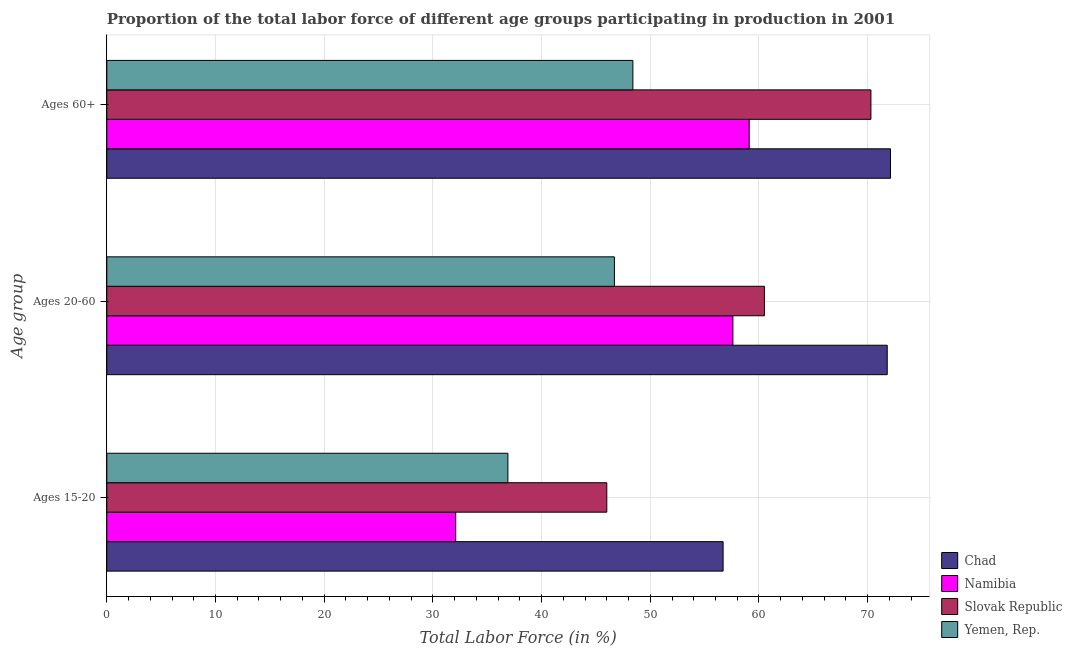Are the number of bars per tick equal to the number of legend labels?
Your response must be concise. Yes. Are the number of bars on each tick of the Y-axis equal?
Your answer should be very brief. Yes. How many bars are there on the 1st tick from the bottom?
Your response must be concise. 4. What is the label of the 2nd group of bars from the top?
Your answer should be compact. Ages 20-60. What is the percentage of labor force within the age group 20-60 in Slovak Republic?
Ensure brevity in your answer.  60.5. Across all countries, what is the maximum percentage of labor force within the age group 20-60?
Make the answer very short. 71.8. Across all countries, what is the minimum percentage of labor force above age 60?
Give a very brief answer. 48.4. In which country was the percentage of labor force within the age group 20-60 maximum?
Ensure brevity in your answer.  Chad. In which country was the percentage of labor force within the age group 20-60 minimum?
Your answer should be very brief. Yemen, Rep. What is the total percentage of labor force above age 60 in the graph?
Keep it short and to the point. 249.9. What is the difference between the percentage of labor force above age 60 in Yemen, Rep. and that in Namibia?
Offer a very short reply. -10.7. What is the difference between the percentage of labor force within the age group 20-60 in Yemen, Rep. and the percentage of labor force within the age group 15-20 in Slovak Republic?
Make the answer very short. 0.7. What is the average percentage of labor force within the age group 15-20 per country?
Provide a succinct answer. 42.93. What is the ratio of the percentage of labor force above age 60 in Namibia to that in Chad?
Give a very brief answer. 0.82. Is the difference between the percentage of labor force above age 60 in Slovak Republic and Namibia greater than the difference between the percentage of labor force within the age group 20-60 in Slovak Republic and Namibia?
Provide a short and direct response. Yes. What is the difference between the highest and the second highest percentage of labor force within the age group 15-20?
Provide a succinct answer. 10.7. What is the difference between the highest and the lowest percentage of labor force above age 60?
Ensure brevity in your answer.  23.7. In how many countries, is the percentage of labor force within the age group 15-20 greater than the average percentage of labor force within the age group 15-20 taken over all countries?
Provide a succinct answer. 2. What does the 1st bar from the top in Ages 60+ represents?
Offer a very short reply. Yemen, Rep. What does the 1st bar from the bottom in Ages 60+ represents?
Give a very brief answer. Chad. Is it the case that in every country, the sum of the percentage of labor force within the age group 15-20 and percentage of labor force within the age group 20-60 is greater than the percentage of labor force above age 60?
Provide a succinct answer. Yes. Are all the bars in the graph horizontal?
Offer a very short reply. Yes. What is the title of the graph?
Ensure brevity in your answer.  Proportion of the total labor force of different age groups participating in production in 2001. Does "Belarus" appear as one of the legend labels in the graph?
Your answer should be compact. No. What is the label or title of the Y-axis?
Offer a very short reply. Age group. What is the Total Labor Force (in %) of Chad in Ages 15-20?
Your answer should be very brief. 56.7. What is the Total Labor Force (in %) of Namibia in Ages 15-20?
Make the answer very short. 32.1. What is the Total Labor Force (in %) in Slovak Republic in Ages 15-20?
Provide a short and direct response. 46. What is the Total Labor Force (in %) of Yemen, Rep. in Ages 15-20?
Your answer should be compact. 36.9. What is the Total Labor Force (in %) of Chad in Ages 20-60?
Offer a terse response. 71.8. What is the Total Labor Force (in %) of Namibia in Ages 20-60?
Make the answer very short. 57.6. What is the Total Labor Force (in %) in Slovak Republic in Ages 20-60?
Your response must be concise. 60.5. What is the Total Labor Force (in %) in Yemen, Rep. in Ages 20-60?
Keep it short and to the point. 46.7. What is the Total Labor Force (in %) in Chad in Ages 60+?
Ensure brevity in your answer.  72.1. What is the Total Labor Force (in %) in Namibia in Ages 60+?
Make the answer very short. 59.1. What is the Total Labor Force (in %) of Slovak Republic in Ages 60+?
Your answer should be very brief. 70.3. What is the Total Labor Force (in %) in Yemen, Rep. in Ages 60+?
Keep it short and to the point. 48.4. Across all Age group, what is the maximum Total Labor Force (in %) in Chad?
Give a very brief answer. 72.1. Across all Age group, what is the maximum Total Labor Force (in %) in Namibia?
Provide a succinct answer. 59.1. Across all Age group, what is the maximum Total Labor Force (in %) in Slovak Republic?
Keep it short and to the point. 70.3. Across all Age group, what is the maximum Total Labor Force (in %) of Yemen, Rep.?
Provide a succinct answer. 48.4. Across all Age group, what is the minimum Total Labor Force (in %) in Chad?
Give a very brief answer. 56.7. Across all Age group, what is the minimum Total Labor Force (in %) of Namibia?
Your answer should be very brief. 32.1. Across all Age group, what is the minimum Total Labor Force (in %) of Yemen, Rep.?
Ensure brevity in your answer.  36.9. What is the total Total Labor Force (in %) in Chad in the graph?
Give a very brief answer. 200.6. What is the total Total Labor Force (in %) in Namibia in the graph?
Your answer should be compact. 148.8. What is the total Total Labor Force (in %) in Slovak Republic in the graph?
Provide a succinct answer. 176.8. What is the total Total Labor Force (in %) of Yemen, Rep. in the graph?
Provide a short and direct response. 132. What is the difference between the Total Labor Force (in %) in Chad in Ages 15-20 and that in Ages 20-60?
Ensure brevity in your answer.  -15.1. What is the difference between the Total Labor Force (in %) in Namibia in Ages 15-20 and that in Ages 20-60?
Ensure brevity in your answer.  -25.5. What is the difference between the Total Labor Force (in %) of Chad in Ages 15-20 and that in Ages 60+?
Make the answer very short. -15.4. What is the difference between the Total Labor Force (in %) of Namibia in Ages 15-20 and that in Ages 60+?
Make the answer very short. -27. What is the difference between the Total Labor Force (in %) of Slovak Republic in Ages 15-20 and that in Ages 60+?
Provide a short and direct response. -24.3. What is the difference between the Total Labor Force (in %) in Chad in Ages 20-60 and that in Ages 60+?
Keep it short and to the point. -0.3. What is the difference between the Total Labor Force (in %) of Yemen, Rep. in Ages 20-60 and that in Ages 60+?
Your response must be concise. -1.7. What is the difference between the Total Labor Force (in %) of Chad in Ages 15-20 and the Total Labor Force (in %) of Namibia in Ages 20-60?
Give a very brief answer. -0.9. What is the difference between the Total Labor Force (in %) of Namibia in Ages 15-20 and the Total Labor Force (in %) of Slovak Republic in Ages 20-60?
Your response must be concise. -28.4. What is the difference between the Total Labor Force (in %) of Namibia in Ages 15-20 and the Total Labor Force (in %) of Yemen, Rep. in Ages 20-60?
Ensure brevity in your answer.  -14.6. What is the difference between the Total Labor Force (in %) of Chad in Ages 15-20 and the Total Labor Force (in %) of Yemen, Rep. in Ages 60+?
Make the answer very short. 8.3. What is the difference between the Total Labor Force (in %) of Namibia in Ages 15-20 and the Total Labor Force (in %) of Slovak Republic in Ages 60+?
Provide a succinct answer. -38.2. What is the difference between the Total Labor Force (in %) of Namibia in Ages 15-20 and the Total Labor Force (in %) of Yemen, Rep. in Ages 60+?
Offer a very short reply. -16.3. What is the difference between the Total Labor Force (in %) of Slovak Republic in Ages 15-20 and the Total Labor Force (in %) of Yemen, Rep. in Ages 60+?
Offer a terse response. -2.4. What is the difference between the Total Labor Force (in %) in Chad in Ages 20-60 and the Total Labor Force (in %) in Namibia in Ages 60+?
Ensure brevity in your answer.  12.7. What is the difference between the Total Labor Force (in %) in Chad in Ages 20-60 and the Total Labor Force (in %) in Slovak Republic in Ages 60+?
Provide a succinct answer. 1.5. What is the difference between the Total Labor Force (in %) in Chad in Ages 20-60 and the Total Labor Force (in %) in Yemen, Rep. in Ages 60+?
Keep it short and to the point. 23.4. What is the difference between the Total Labor Force (in %) of Namibia in Ages 20-60 and the Total Labor Force (in %) of Slovak Republic in Ages 60+?
Ensure brevity in your answer.  -12.7. What is the difference between the Total Labor Force (in %) of Namibia in Ages 20-60 and the Total Labor Force (in %) of Yemen, Rep. in Ages 60+?
Your answer should be compact. 9.2. What is the difference between the Total Labor Force (in %) in Slovak Republic in Ages 20-60 and the Total Labor Force (in %) in Yemen, Rep. in Ages 60+?
Provide a succinct answer. 12.1. What is the average Total Labor Force (in %) in Chad per Age group?
Offer a very short reply. 66.87. What is the average Total Labor Force (in %) in Namibia per Age group?
Your answer should be compact. 49.6. What is the average Total Labor Force (in %) in Slovak Republic per Age group?
Provide a short and direct response. 58.93. What is the difference between the Total Labor Force (in %) of Chad and Total Labor Force (in %) of Namibia in Ages 15-20?
Provide a short and direct response. 24.6. What is the difference between the Total Labor Force (in %) of Chad and Total Labor Force (in %) of Slovak Republic in Ages 15-20?
Make the answer very short. 10.7. What is the difference between the Total Labor Force (in %) in Chad and Total Labor Force (in %) in Yemen, Rep. in Ages 15-20?
Give a very brief answer. 19.8. What is the difference between the Total Labor Force (in %) in Chad and Total Labor Force (in %) in Namibia in Ages 20-60?
Keep it short and to the point. 14.2. What is the difference between the Total Labor Force (in %) in Chad and Total Labor Force (in %) in Slovak Republic in Ages 20-60?
Your answer should be compact. 11.3. What is the difference between the Total Labor Force (in %) in Chad and Total Labor Force (in %) in Yemen, Rep. in Ages 20-60?
Your answer should be compact. 25.1. What is the difference between the Total Labor Force (in %) in Chad and Total Labor Force (in %) in Slovak Republic in Ages 60+?
Your answer should be compact. 1.8. What is the difference between the Total Labor Force (in %) in Chad and Total Labor Force (in %) in Yemen, Rep. in Ages 60+?
Ensure brevity in your answer.  23.7. What is the difference between the Total Labor Force (in %) in Namibia and Total Labor Force (in %) in Slovak Republic in Ages 60+?
Offer a very short reply. -11.2. What is the difference between the Total Labor Force (in %) in Slovak Republic and Total Labor Force (in %) in Yemen, Rep. in Ages 60+?
Offer a terse response. 21.9. What is the ratio of the Total Labor Force (in %) in Chad in Ages 15-20 to that in Ages 20-60?
Your answer should be very brief. 0.79. What is the ratio of the Total Labor Force (in %) of Namibia in Ages 15-20 to that in Ages 20-60?
Give a very brief answer. 0.56. What is the ratio of the Total Labor Force (in %) of Slovak Republic in Ages 15-20 to that in Ages 20-60?
Ensure brevity in your answer.  0.76. What is the ratio of the Total Labor Force (in %) in Yemen, Rep. in Ages 15-20 to that in Ages 20-60?
Give a very brief answer. 0.79. What is the ratio of the Total Labor Force (in %) in Chad in Ages 15-20 to that in Ages 60+?
Your answer should be very brief. 0.79. What is the ratio of the Total Labor Force (in %) in Namibia in Ages 15-20 to that in Ages 60+?
Your response must be concise. 0.54. What is the ratio of the Total Labor Force (in %) of Slovak Republic in Ages 15-20 to that in Ages 60+?
Make the answer very short. 0.65. What is the ratio of the Total Labor Force (in %) in Yemen, Rep. in Ages 15-20 to that in Ages 60+?
Your answer should be compact. 0.76. What is the ratio of the Total Labor Force (in %) of Chad in Ages 20-60 to that in Ages 60+?
Offer a terse response. 1. What is the ratio of the Total Labor Force (in %) of Namibia in Ages 20-60 to that in Ages 60+?
Offer a terse response. 0.97. What is the ratio of the Total Labor Force (in %) in Slovak Republic in Ages 20-60 to that in Ages 60+?
Your answer should be compact. 0.86. What is the ratio of the Total Labor Force (in %) in Yemen, Rep. in Ages 20-60 to that in Ages 60+?
Keep it short and to the point. 0.96. What is the difference between the highest and the second highest Total Labor Force (in %) of Chad?
Provide a succinct answer. 0.3. What is the difference between the highest and the second highest Total Labor Force (in %) of Namibia?
Offer a terse response. 1.5. What is the difference between the highest and the second highest Total Labor Force (in %) of Slovak Republic?
Your answer should be very brief. 9.8. What is the difference between the highest and the lowest Total Labor Force (in %) in Slovak Republic?
Offer a terse response. 24.3. What is the difference between the highest and the lowest Total Labor Force (in %) in Yemen, Rep.?
Give a very brief answer. 11.5. 